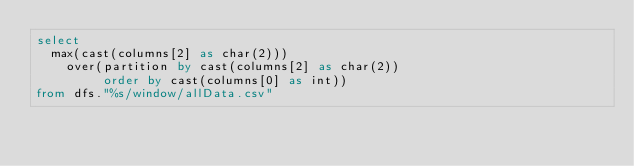<code> <loc_0><loc_0><loc_500><loc_500><_SQL_>select
  max(cast(columns[2] as char(2)))
    over(partition by cast(columns[2] as char(2))
         order by cast(columns[0] as int))
from dfs."%s/window/allData.csv"
</code> 